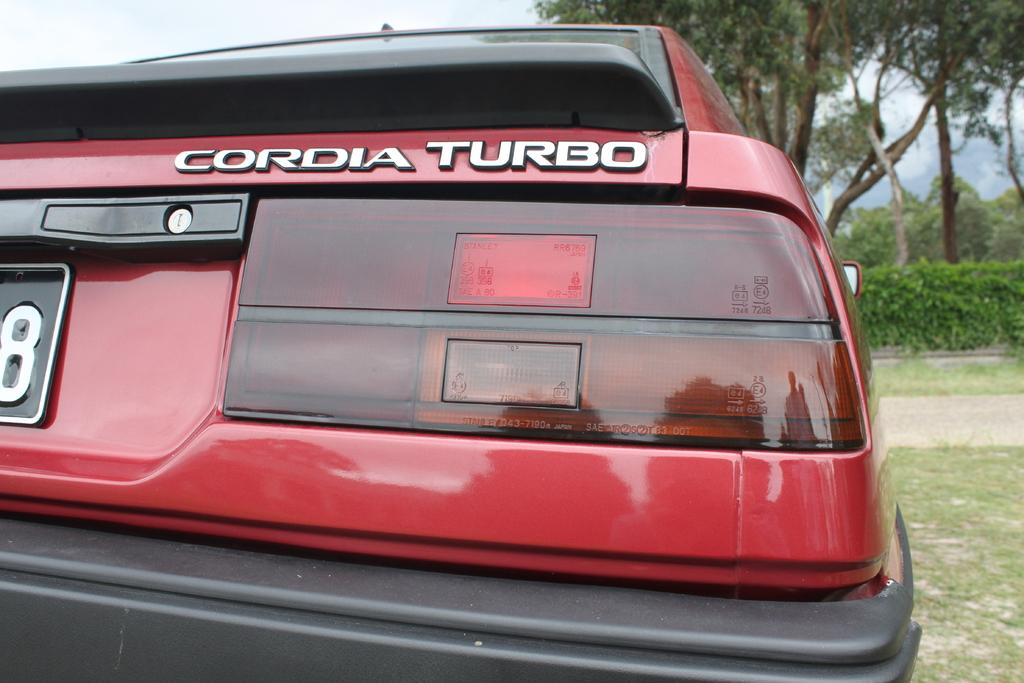<image>
Describe the image concisely. The taillight of a red Cordia Turbo vehicle. 